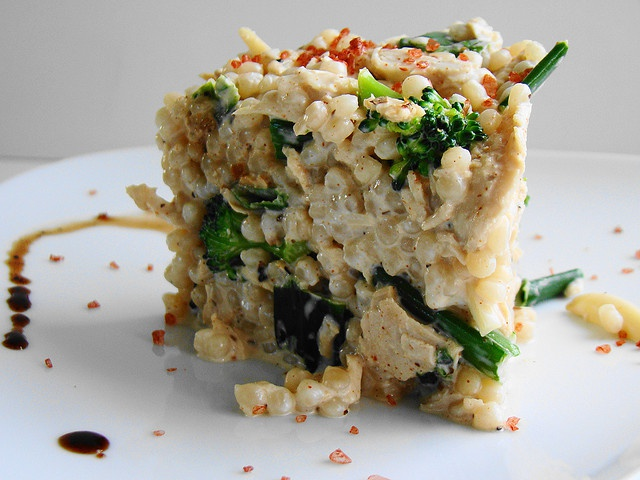Describe the objects in this image and their specific colors. I can see broccoli in darkgray, black, darkgreen, khaki, and olive tones, broccoli in darkgray, black, darkgreen, and gray tones, and broccoli in darkgray, black, gray, and darkgreen tones in this image. 